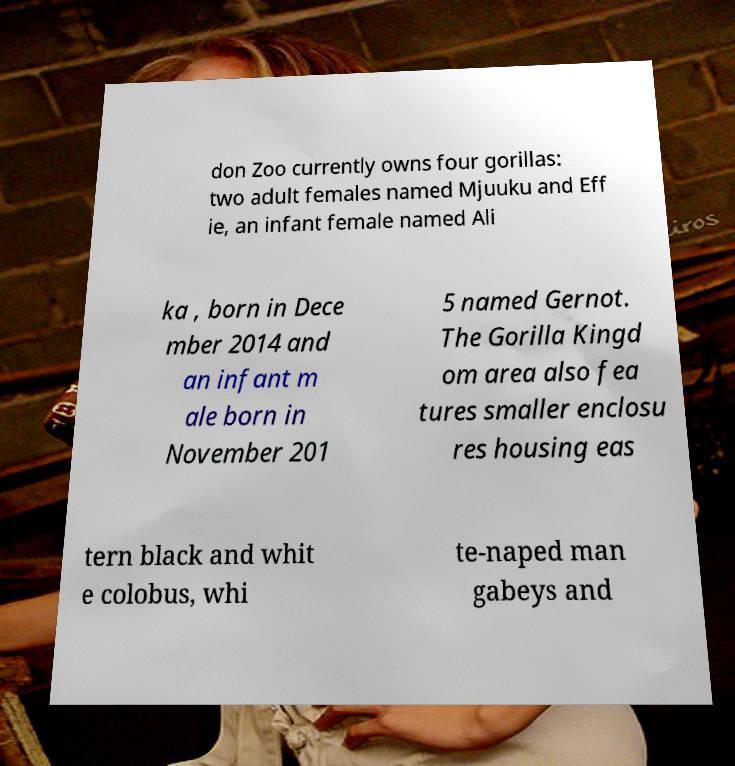There's text embedded in this image that I need extracted. Can you transcribe it verbatim? don Zoo currently owns four gorillas: two adult females named Mjuuku and Eff ie, an infant female named Ali ka , born in Dece mber 2014 and an infant m ale born in November 201 5 named Gernot. The Gorilla Kingd om area also fea tures smaller enclosu res housing eas tern black and whit e colobus, whi te-naped man gabeys and 